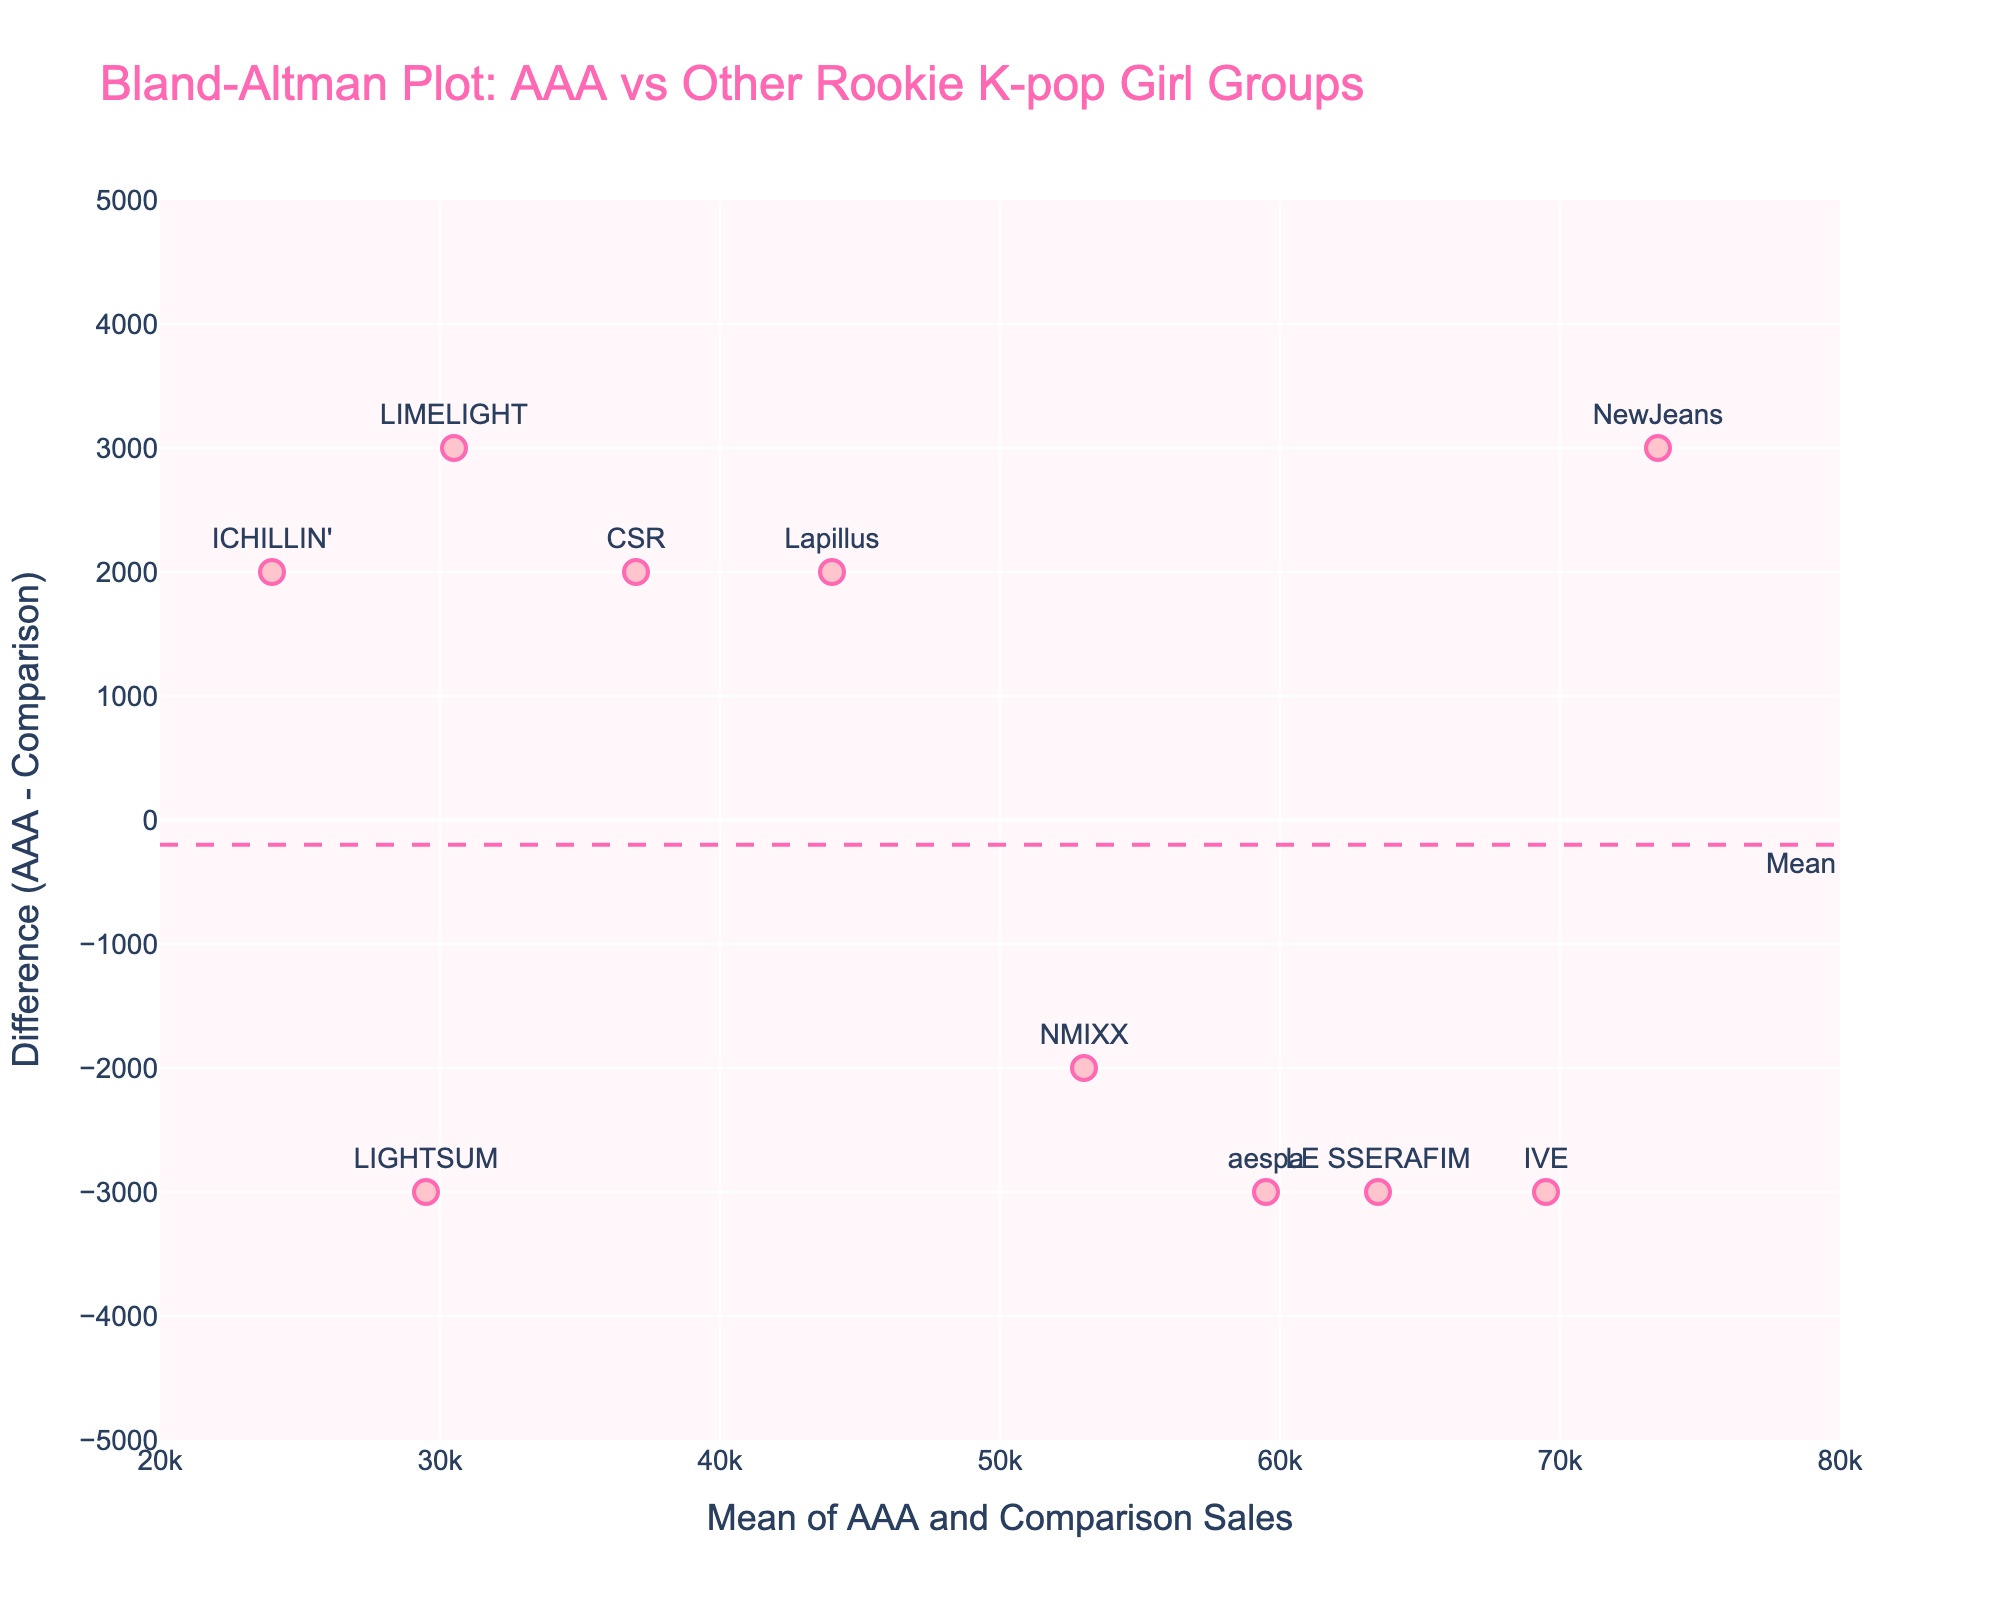What is the overall title of the Bland-Altman plot? The title is usually displayed at the top center of the figure. It provides a summary or the main topic that the plot is addressing.
Answer: Bland-Altman Plot: AAA vs Other Rookie K-pop Girl Groups How many data points are represented in the plot? The number of data points corresponds to the total number of groups compared in the plot. Each point usually represents one group.
Answer: 10 Which group has the largest difference between AAA sales and Comparison sales? Identify the point with the highest or lowest vertical position on the plot. The group label near this point indicates which group it is.
Answer: NewJeans What is the average sales value for the group IVE, based on the plot? To find this, look at the position of the group IVE on the x-axis, which represents the mean sales value of AAA and Comparison groups.
Answer: 69500 Are there more points above or below the mean difference line? Visually count the number of points above and below the horizontal dashed line, which represents the mean difference.
Answer: More points below Which groups fall outside the 1.96 standard deviation limits? Identify the points that lie above the "+1.96 SD" line or below the "-1.96 SD" line, representing the outliers of the agreement limits.
Answer: NewJeans, LIMELIGHT Which group lies closest to the mean difference line? Find the point that is closest to the horizontal line labeled "Mean".
Answer: LAPILLUS What is the range of the horizontal (x-axis) values in the plot? The axis range can be found at the bottom of the plot, usually specified by the minimum and maximum values.
Answer: 20000 to 80000 How does the sales comparison of LIGHTSUM and ICHILLIN' to AAA differ? Which group performs better in comparison to AAA? Compare the vertical positions of the points for LIGHTSUM and ICHILLIN'. The one closer to the zero line has a smaller difference, indicating better performance relative to AAA.
Answer: ICHILLIN' What is the overall trend of the difference between AAA sales and Comparison sales across the means? Examine the general pattern of points as you move along the x-axis from left to right. If the points don’t show a consistent upward or downward trend, it means that there's no clear systematic bias.
Answer: No clear trend 